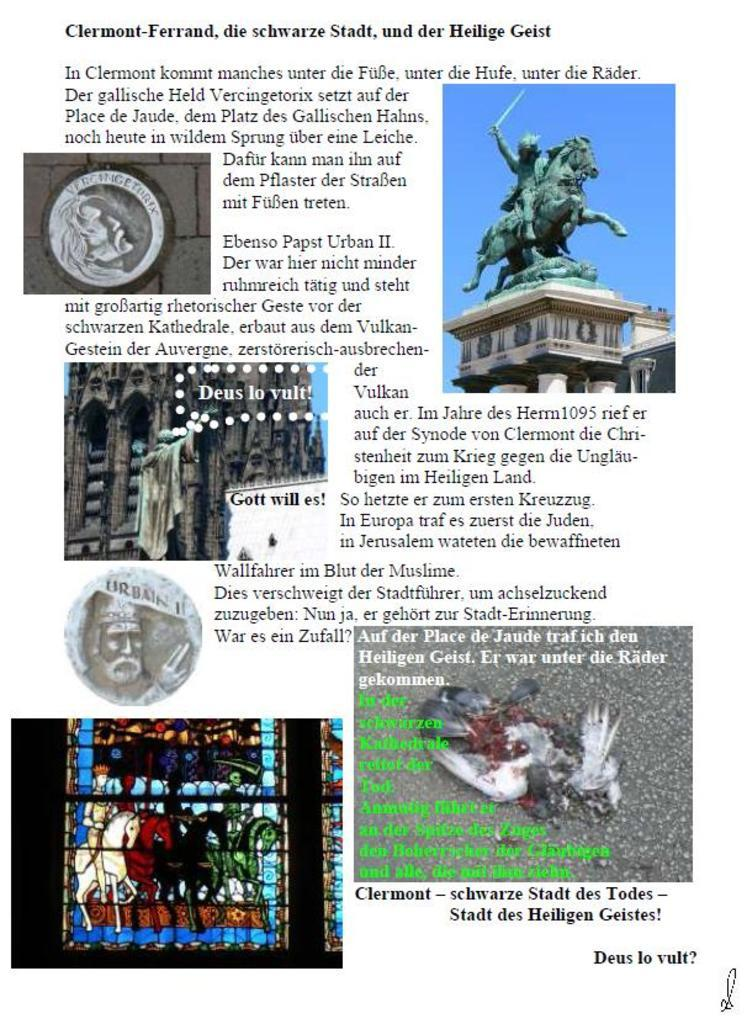What is the main subject in the image? There is a statue in the image. Can you describe any other elements in the image? A person's face is visible in the image, and the sky is also visible. Is there any text or writing in the image? Yes, there is something written on the image. What grade did the person receive for their disgust in the image? There is no mention of disgust or grades in the image; it features a statue, a person's face, the sky, and some writing. 